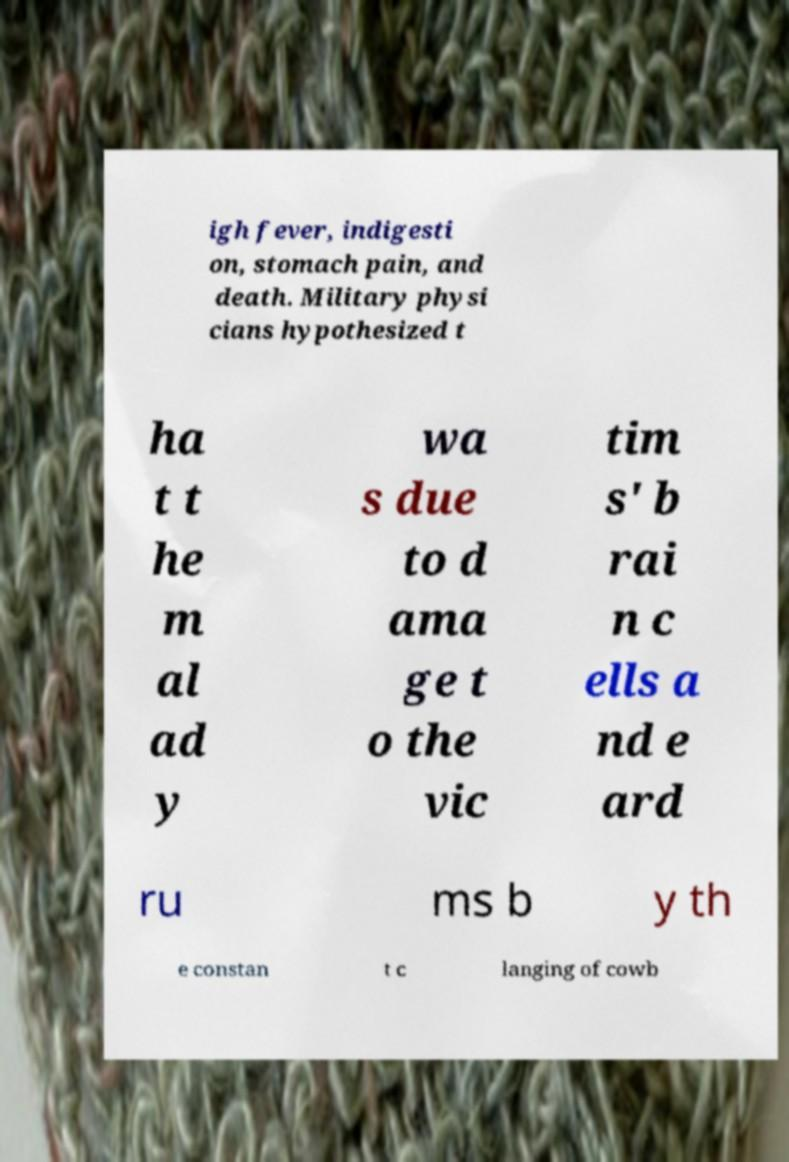Please identify and transcribe the text found in this image. igh fever, indigesti on, stomach pain, and death. Military physi cians hypothesized t ha t t he m al ad y wa s due to d ama ge t o the vic tim s' b rai n c ells a nd e ard ru ms b y th e constan t c langing of cowb 